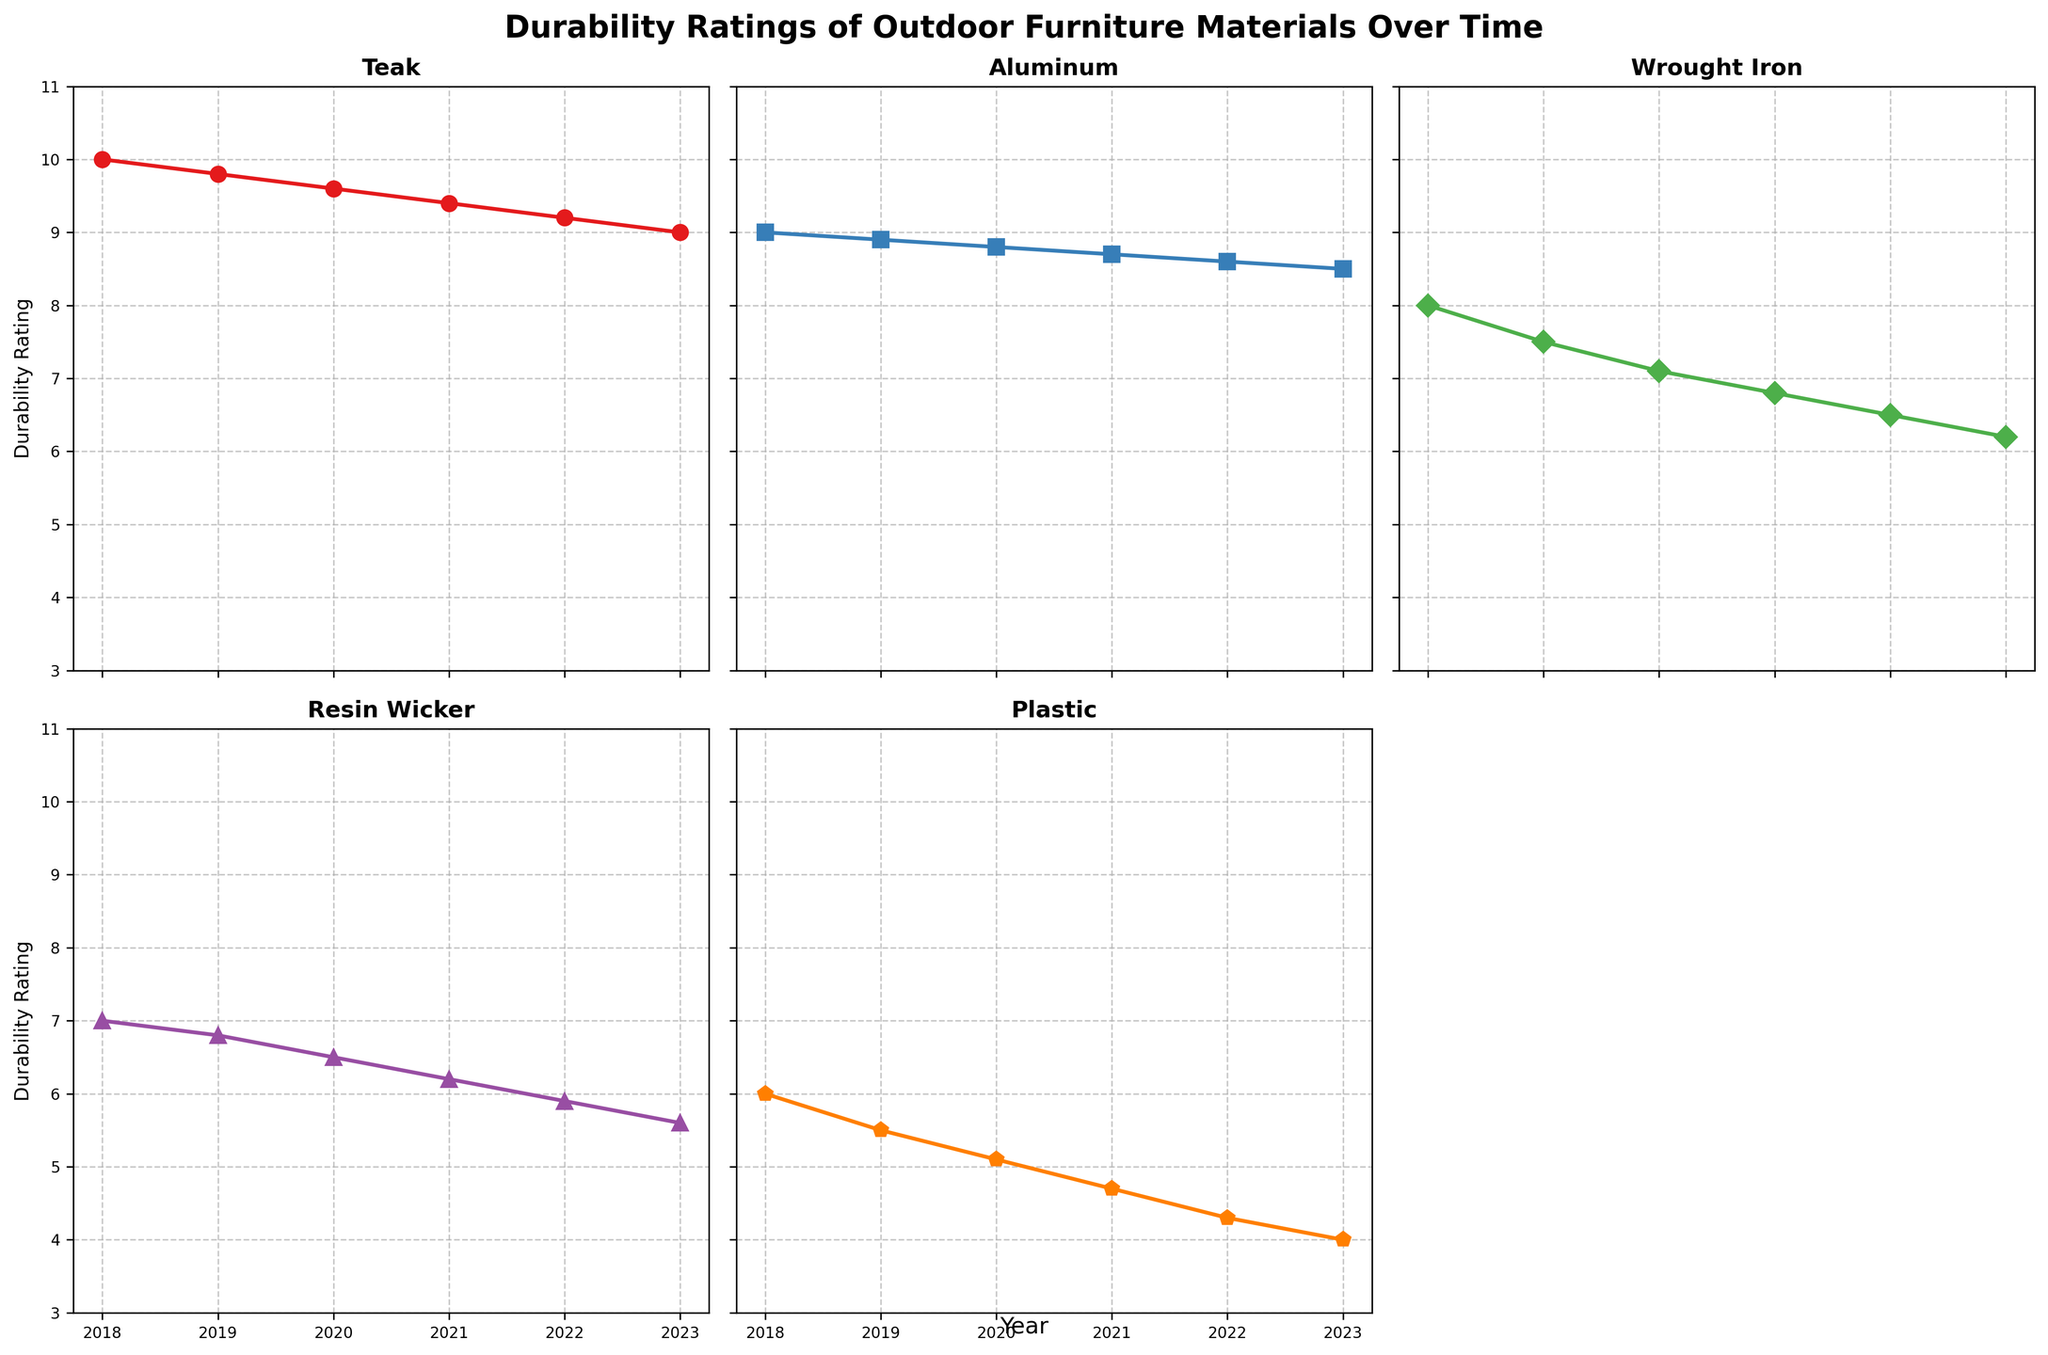What's the title of the figure? The title of the figure is usually positioned at the top center of the chart and provides a summary of what the chart displays. Here, it is "Durability Ratings of Outdoor Furniture Materials Over Time."
Answer: Durability Ratings of Outdoor Furniture Materials Over Time What is the overall trend for Teak from 2018 to 2023? To find the trend for Teak, observe the line representing Teak from 2018 to 2023. The line starts at a high value in 2018 and gradually declines until 2023.
Answer: Gradually declining Which material had the steadiest durability rating over the years? Comparing the slopes of each line across the years helps identify the steadiest durability rating. The Aluminum line has the slightest decline compared to others, indicating it had the steadiest durability rating.
Answer: Aluminum What was the durability rating of Plastic in 2020? Look at the point on the Plastic line that corresponds to the year 2020. The rating is located on the vertical axis labeled "Durability Rating."
Answer: 5.1 How many materials are displayed in the plot? Count the number of individual material lines or names listed in separate subplots. There are subplots for Teak, Aluminum, Wrought Iron, Resin Wicker, and Plastic.
Answer: 5 Between which consecutive years did Resin Wicker decline the most? Calculate the difference in Resin Wicker's rating between each consecutive year and compare. The largest decline is between 2018 and 2019, where it drops from 7 to 6.8.
Answer: 2018 and 2019 Which material had the lowest durability rating in 2023? Compare the endpoints of all lines in 2023. The line for Plastic ends at the lowest point on the vertical axis.
Answer: Plastic By how much did the durability rating for Wrought Iron decrease from 2018 to 2023? Subtract the 2023 rating from the 2018 rating for Wrought Iron. The decrease is from 8 to 6.2, which is 1.8.
Answer: 1.8 How does the trend of Resin Wicker compare to that of Plastic? Observe the overall direction and steepness of the lines for both Resin Wicker and Plastic. Both lines show a decline, but the Plastic line has a steeper negative slope, indicating a more rapid decrease than Resin Wicker's.
Answer: Plastic declined more rapidly Which material had the highest durability rating in 2021? Look at the plotted points for each material for the year 2021. The highest point corresponds to the Teak line with a rating of 9.4.
Answer: Teak 